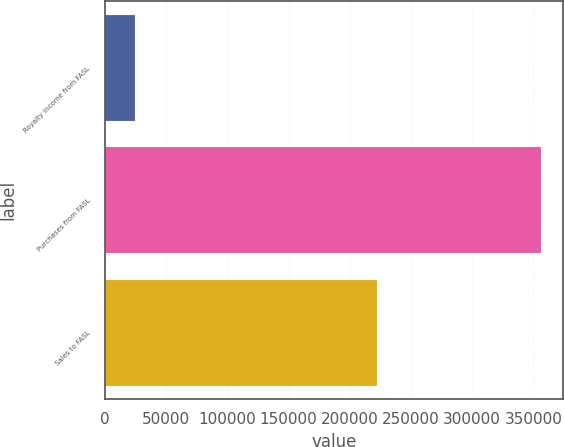<chart> <loc_0><loc_0><loc_500><loc_500><bar_chart><fcel>Royalty income from FASL<fcel>Purchases from FASL<fcel>Sales to FASL<nl><fcel>24611<fcel>356595<fcel>222570<nl></chart> 